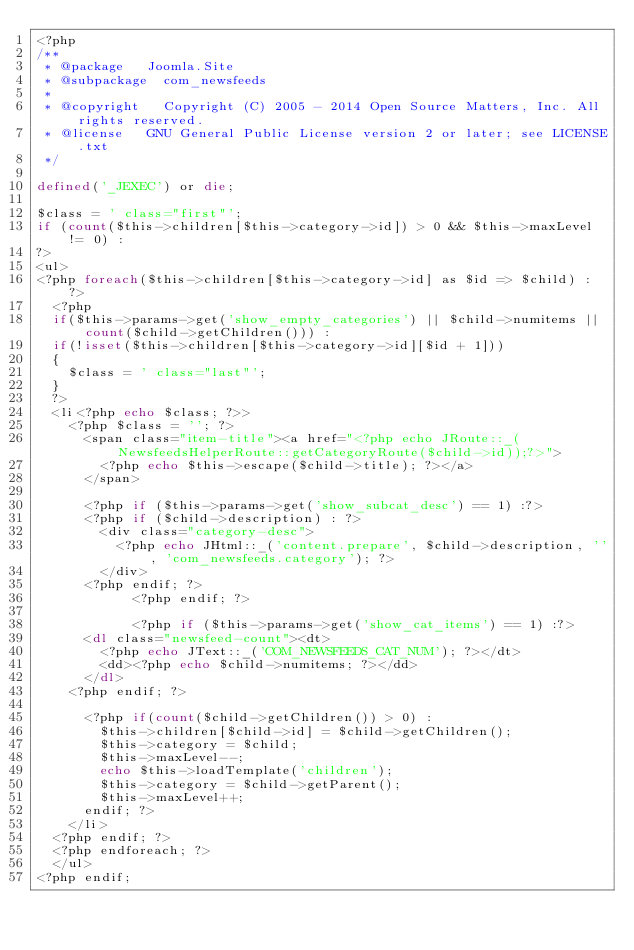Convert code to text. <code><loc_0><loc_0><loc_500><loc_500><_PHP_><?php
/**
 * @package		Joomla.Site
 * @subpackage	com_newsfeeds
 *
 * @copyright   Copyright (C) 2005 - 2014 Open Source Matters, Inc. All rights reserved.
 * @license		GNU General Public License version 2 or later; see LICENSE.txt
 */

defined('_JEXEC') or die;

$class = ' class="first"';
if (count($this->children[$this->category->id]) > 0 && $this->maxLevel != 0) :
?>
<ul>
<?php foreach($this->children[$this->category->id] as $id => $child) : ?>
	<?php
	if($this->params->get('show_empty_categories') || $child->numitems || count($child->getChildren())) :
	if(!isset($this->children[$this->category->id][$id + 1]))
	{
		$class = ' class="last"';
	}
	?>
	<li<?php echo $class; ?>>
		<?php $class = ''; ?>
			<span class="item-title"><a href="<?php echo JRoute::_(NewsfeedsHelperRoute::getCategoryRoute($child->id));?>">
				<?php echo $this->escape($child->title); ?></a>
			</span>

			<?php if ($this->params->get('show_subcat_desc') == 1) :?>
			<?php if ($child->description) : ?>
				<div class="category-desc">
					<?php echo JHtml::_('content.prepare', $child->description, '', 'com_newsfeeds.category'); ?>
				</div>
			<?php endif; ?>
            <?php endif; ?>

            <?php if ($this->params->get('show_cat_items') == 1) :?>
			<dl class="newsfeed-count"><dt>
				<?php echo JText::_('COM_NEWSFEEDS_CAT_NUM'); ?></dt>
				<dd><?php echo $child->numitems; ?></dd>
			</dl>
		<?php endif; ?>

			<?php if(count($child->getChildren()) > 0) :
				$this->children[$child->id] = $child->getChildren();
				$this->category = $child;
				$this->maxLevel--;
				echo $this->loadTemplate('children');
				$this->category = $child->getParent();
				$this->maxLevel++;
			endif; ?>
		</li>
	<?php endif; ?>
	<?php endforeach; ?>
	</ul>
<?php endif;
</code> 